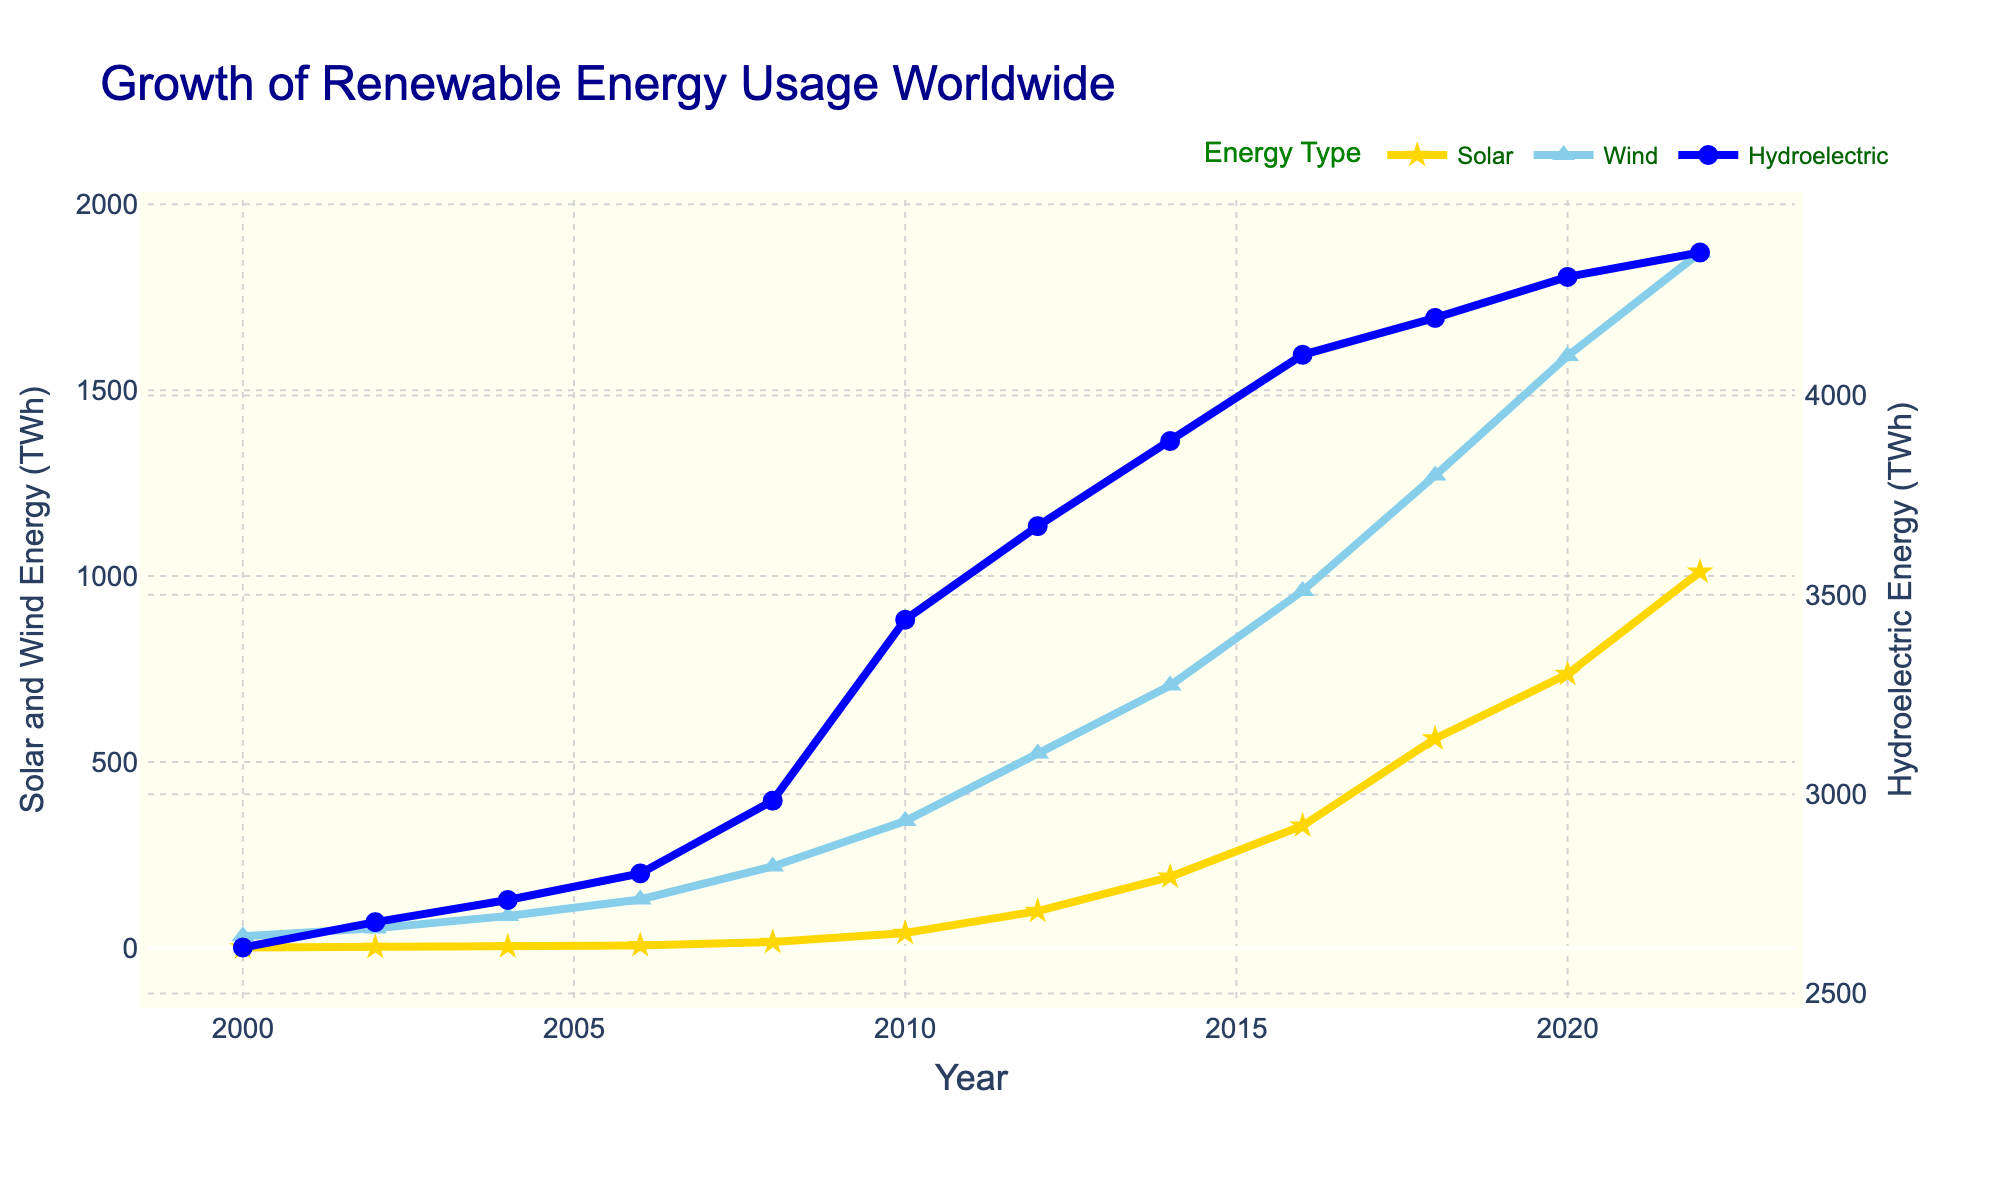What year did solar energy usage surpass 500 TWh? From the chart, follow the Solar energy line until it passes the 500 TWh mark. This happens between 2016 and 2018, and by 2018, it surpasses 500 TWh.
Answer: 2018 Which type of renewable energy had the highest usage in 2022? From the chart, look at the endpoint of each energy type's line in 2022. Hydroelectric energy shows the highest value.
Answer: Hydroelectric By how much did wind energy usage increase from 2010 to 2022? Notice wind energy usage in 2010 (341.5 TWh) and 2022 (1870.3 TWh). Subtract 341.5 from 1870.3 to find the increase. 1870.3 - 341.5 = 1528.8
Answer: 1528.8 TWh Did hydroelectric energy usage increase faster than solar energy from 2000 to 2022? Compare the slope of the Hydroelectric and Solar lines. Hydroelectric follows a relatively steady, less steep slope, whereas Solar shows a more dramatic increase, indicating faster growth.
Answer: No What was the average wind energy usage between 2000 and 2022? Sum the wind energy values: 31.4 + 52.6 + 85.7 + 130.4 + 219.1 + 341.5 + 522.7 + 705.8 + 960.2 + 1270.4 + 1592.1 + 1870.3 = 7782.2. Divide by 12 years, 7782.2 / 12 ≈ 648.52
Answer: 648.52 TWh In what year did solar energy reach approximately the same level as wind energy in 2008? Locate on the chart where the Solar line reaches around 219.1 TWh, achieved by wind in 2008, which occurs in 2014 for Solar.
Answer: 2014 How much did hydroelectric energy usage increase between 2004 and 2014? Note hydroelectric usage in 2004 (2734.5 TWh) and 2014 (3885.9 TWh). Subtract 2734.5 from 3885.9 to determine the increase. 3885.9 - 2734.5 = 1151.4
Answer: 1151.4 TWh Compare the growth rate of solar energy between 2006 and 2012 to that of wind energy in the same period. Observe the steepness of both lines. Solar grew from 6.9 TWh to 99.1 TWh (92.2 TWh increase), while wind grew from 130.4 TWh to 522.7 TWh (392.3 TWh increase). Wind increased significantly more, showing a higher growth rate.
Answer: Wind energy grew faster What was the total usage of solar and wind energy in 2020? Sum of Solar (736.5 TWh) and Wind (1592.1 TWh) in 2020: 736.5 + 1592.1 = 2328.6
Answer: 2328.6 TWh By what factor did solar energy usage multiply from 2000 to 2022? Solar energy was 1.2 TWh in 2000 and 1011.2 TWh in 2022. Divide the 2022 value by the 2000 value: 1011.2 / 1.2 ≈ 842.67
Answer: ≈842.67 